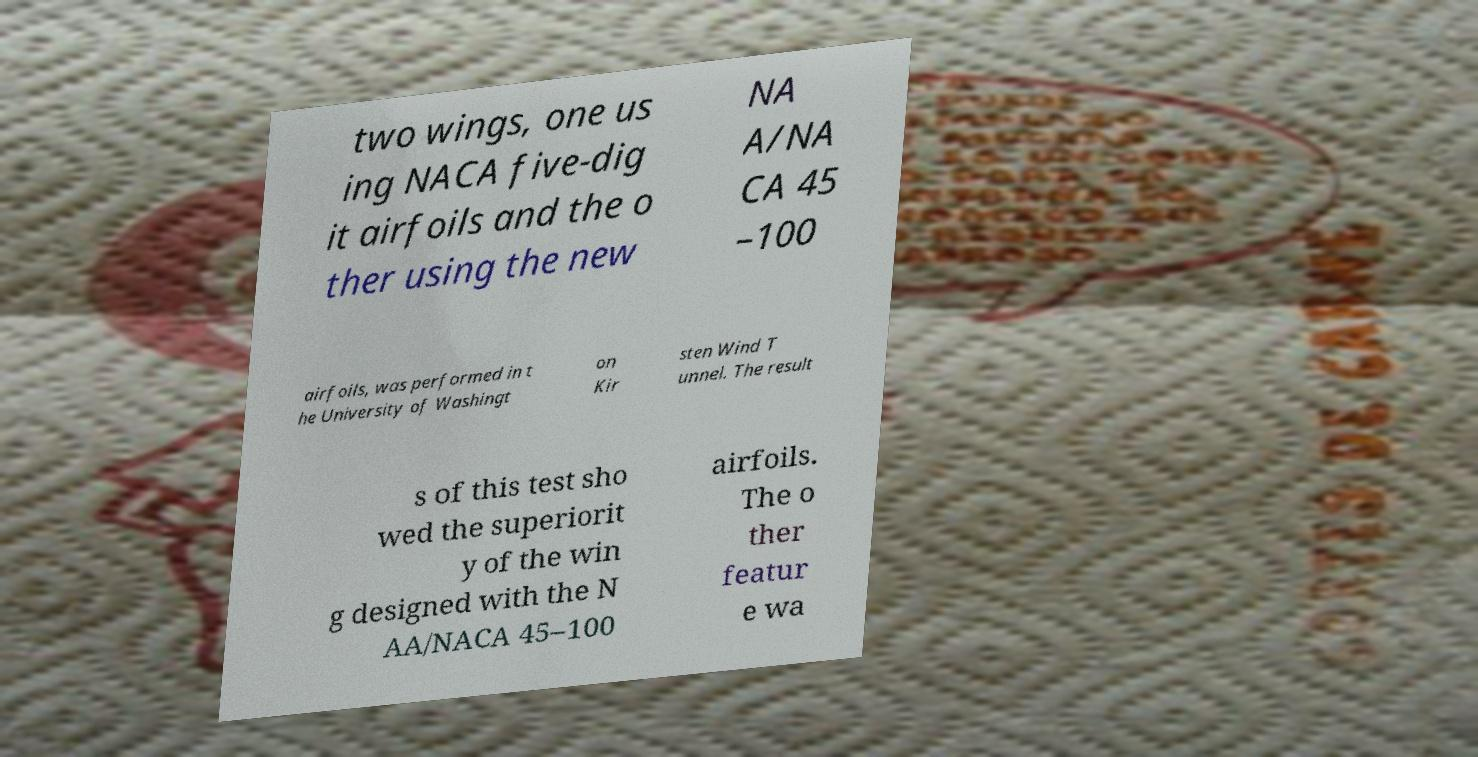Can you read and provide the text displayed in the image?This photo seems to have some interesting text. Can you extract and type it out for me? two wings, one us ing NACA five-dig it airfoils and the o ther using the new NA A/NA CA 45 –100 airfoils, was performed in t he University of Washingt on Kir sten Wind T unnel. The result s of this test sho wed the superiorit y of the win g designed with the N AA/NACA 45–100 airfoils. The o ther featur e wa 